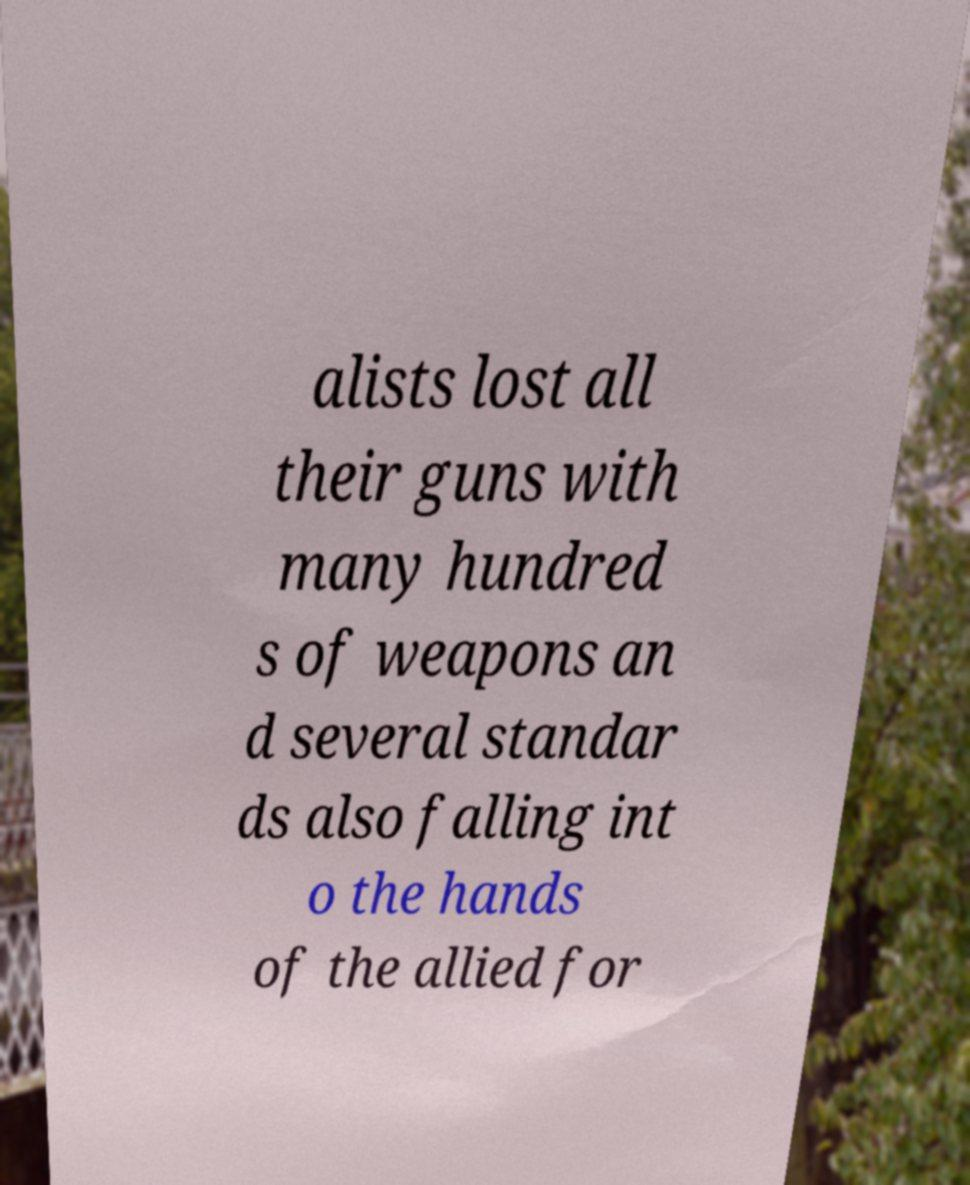There's text embedded in this image that I need extracted. Can you transcribe it verbatim? alists lost all their guns with many hundred s of weapons an d several standar ds also falling int o the hands of the allied for 